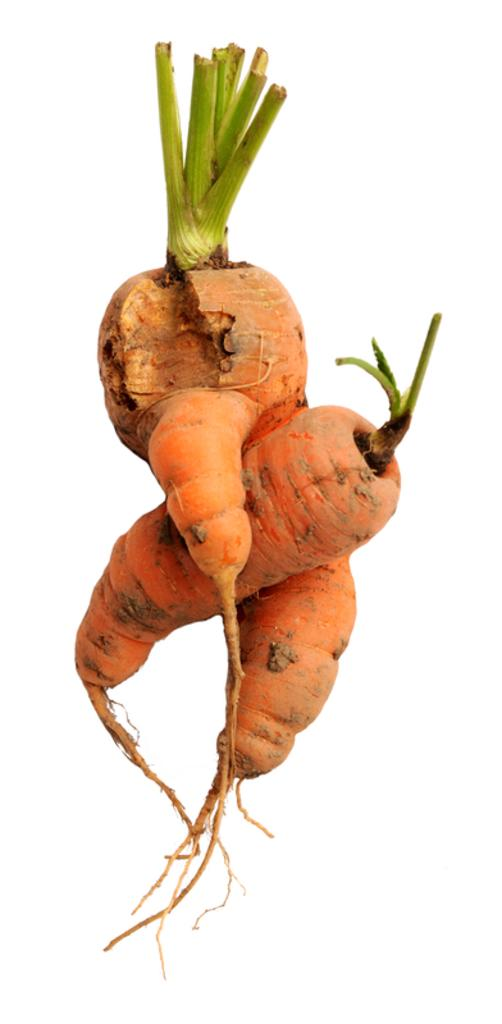What type of vegetable is present in the image? There are carrots in the image. What color is the background of the image? The background of the image is white. What type of request can be seen written on the carrots in the image? There is no request written on the carrots in the image; they are simply vegetables. 